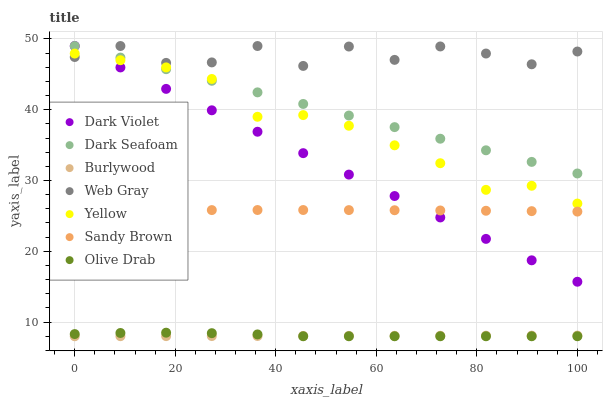Does Burlywood have the minimum area under the curve?
Answer yes or no. Yes. Does Web Gray have the maximum area under the curve?
Answer yes or no. Yes. Does Yellow have the minimum area under the curve?
Answer yes or no. No. Does Yellow have the maximum area under the curve?
Answer yes or no. No. Is Burlywood the smoothest?
Answer yes or no. Yes. Is Web Gray the roughest?
Answer yes or no. Yes. Is Yellow the smoothest?
Answer yes or no. No. Is Yellow the roughest?
Answer yes or no. No. Does Burlywood have the lowest value?
Answer yes or no. Yes. Does Yellow have the lowest value?
Answer yes or no. No. Does Dark Violet have the highest value?
Answer yes or no. Yes. Does Yellow have the highest value?
Answer yes or no. No. Is Sandy Brown less than Dark Seafoam?
Answer yes or no. Yes. Is Yellow greater than Olive Drab?
Answer yes or no. Yes. Does Dark Violet intersect Yellow?
Answer yes or no. Yes. Is Dark Violet less than Yellow?
Answer yes or no. No. Is Dark Violet greater than Yellow?
Answer yes or no. No. Does Sandy Brown intersect Dark Seafoam?
Answer yes or no. No. 